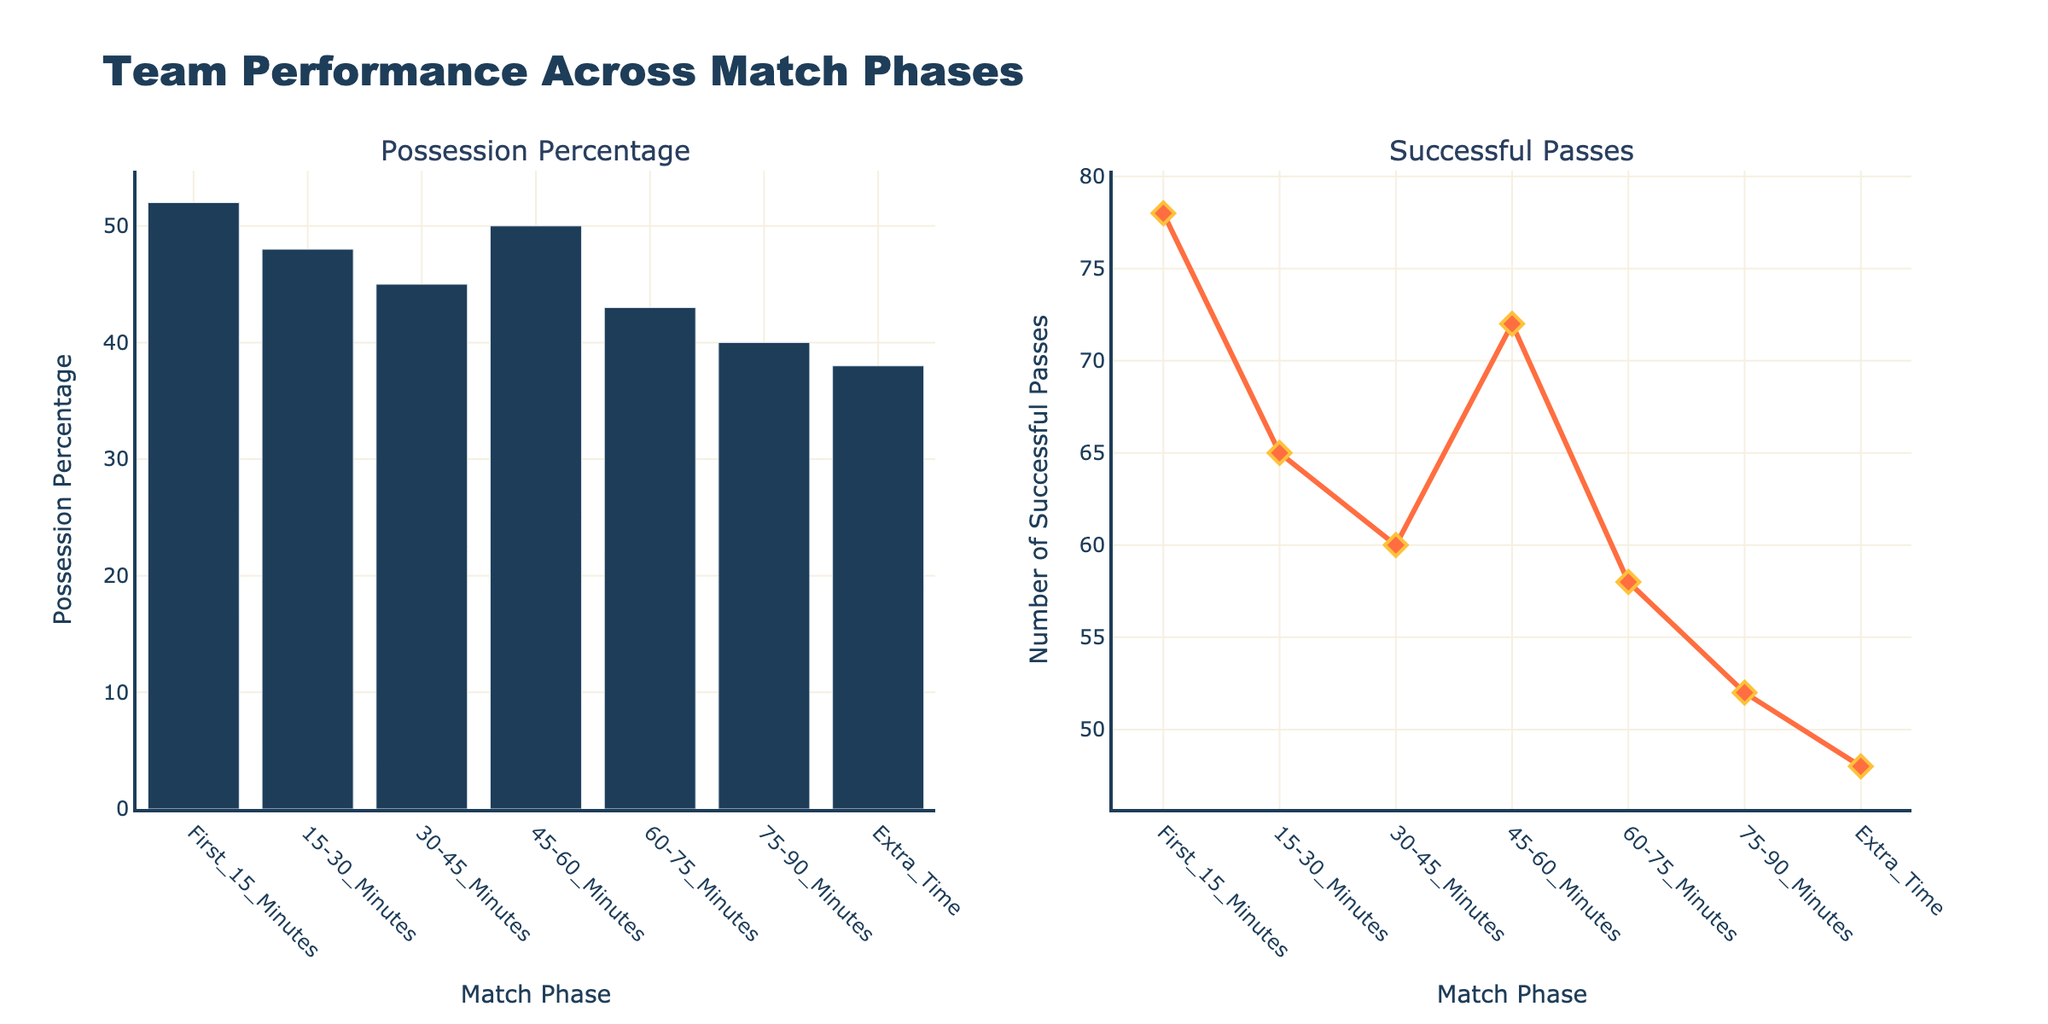How many match phases are depicted in the figure? The x-axis of both subplots shows different match phases. Counting the distinct labels (First 15 Minutes, 15-30 Minutes, etc.) reveals the total number of match phases.
Answer: Seven What is the possession percentage during the First 15 Minutes of the match? The bar chart on the left side of the figure shows the possession percentage for each match phase. Look for the bar labeled "First 15 Minutes" and read its value.
Answer: 52% Which match phase has the lowest number of successful passes? In the line chart on the right side of the figure, find the lowest point on the plot and note the corresponding x-axis label.
Answer: Extra Time How does the possession percentage trend over the course of the match? Observe the heights of the bars from left to right in the bar chart. Notice if they are increasing, decreasing, or staying the same as the match progresses.
Answer: Decreasing By how much does the possession percentage decrease from the First 15 Minutes to the 75-90 Minutes phase? Find the possession percentage values for "First 15 Minutes" and "75-90 Minutes" and calculate the difference: 52 - 40 = 12.
Answer: 12% What’s the average number of successful passes between the 45-60 Minutes and 60-75 Minutes phases? First, find the number of successful passes for the 45-60 Minutes (72) and 60-75 Minutes (58) phases. Then, calculate the average: (72 + 58) / 2 = 65.
Answer: 65 Which match phase shows the largest drop in possession percentage compared to the previous phase? Compare the possession percentages between consecutive match phases and identify the largest decline.
Answer: 30-45 Minutes to 45-60 Minutes (5% drop) How do the trends in possession percentage compare to the trends in successful passes? Compare the overall shapes and directions of the bar chart (possession) and the line chart (successful passes) to see if they follow similar or different patterns.
Answer: Both trends decrease over time What is the possession percentage halfway through the match? Identify the possession percentage for the 45-60 Minutes phase, which represents the midpoint of a regular 90-minute match.
Answer: 50% In which match phase is the difference between possession percentage and successful passes greatest? Calculate the difference between the possession percentage and successful passes for each phase, and identify the phase with the greatest difference. Possession - Passes for each phase: 52-78, 48-65, 45-60, 50-72, 43-58, 40-52, 38-48. The greatest difference occurs in the First 15 Minutes: 52 - 78 = -26.
Answer: First 15 Minutes 